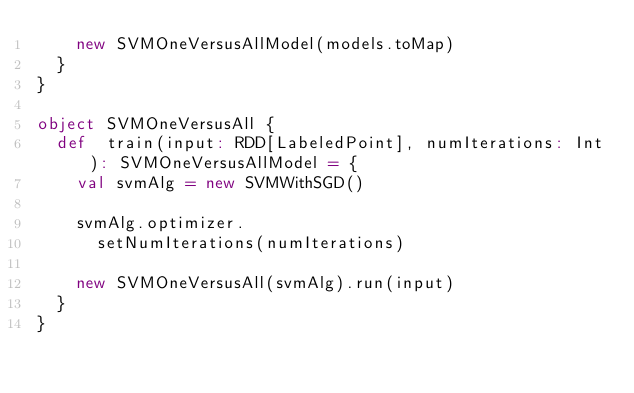Convert code to text. <code><loc_0><loc_0><loc_500><loc_500><_Scala_>    new SVMOneVersusAllModel(models.toMap)
  }
}

object SVMOneVersusAll {
  def  train(input: RDD[LabeledPoint], numIterations: Int): SVMOneVersusAllModel = {
    val svmAlg = new SVMWithSGD()

    svmAlg.optimizer.
      setNumIterations(numIterations)

    new SVMOneVersusAll(svmAlg).run(input)
  }
}</code> 